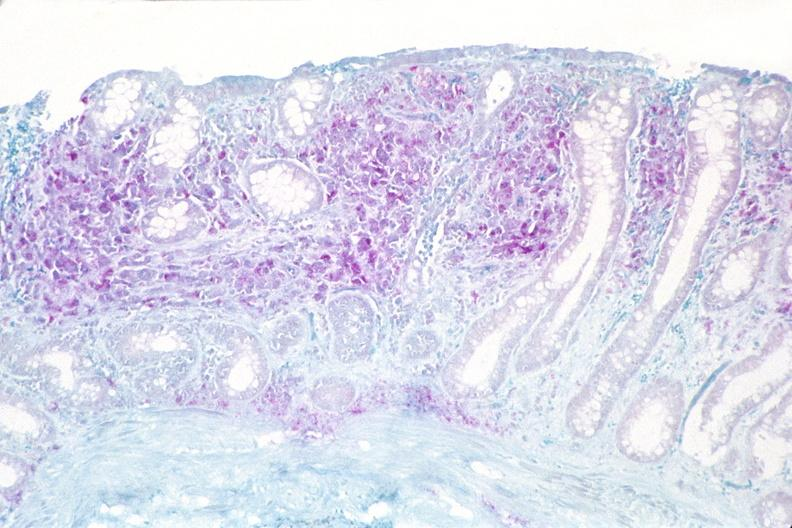what is present?
Answer the question using a single word or phrase. Gastrointestinal 